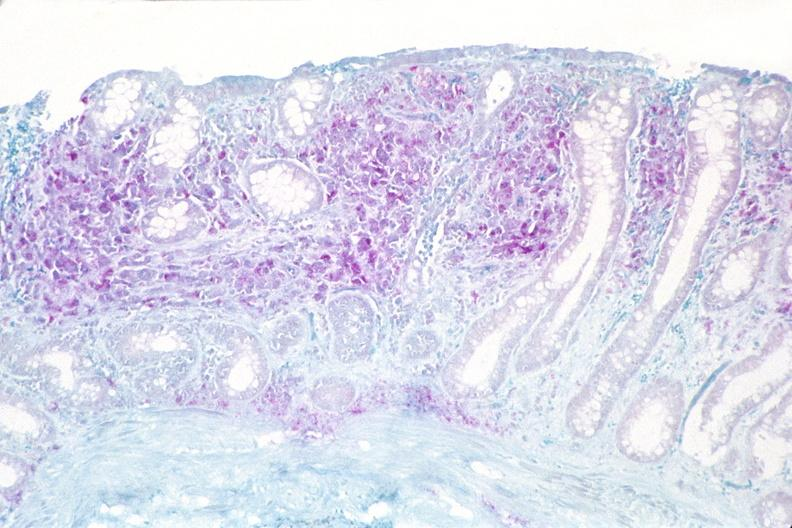what is present?
Answer the question using a single word or phrase. Gastrointestinal 